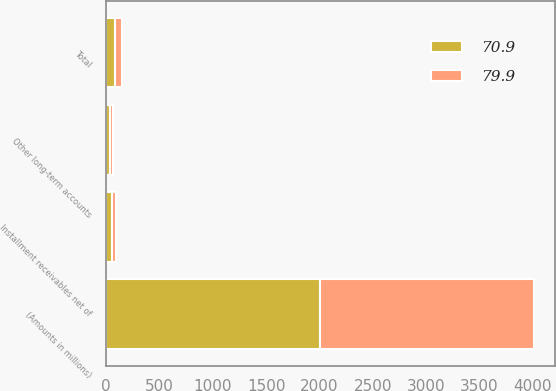Convert chart to OTSL. <chart><loc_0><loc_0><loc_500><loc_500><stacked_bar_chart><ecel><fcel>(Amounts in millions)<fcel>Installment receivables net of<fcel>Other long-term accounts<fcel>Total<nl><fcel>70.9<fcel>2007<fcel>49.2<fcel>30.7<fcel>79.9<nl><fcel>79.9<fcel>2006<fcel>42.6<fcel>28.3<fcel>70.9<nl></chart> 